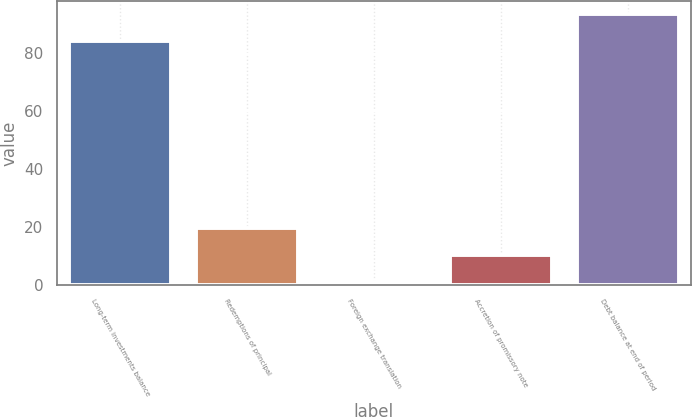<chart> <loc_0><loc_0><loc_500><loc_500><bar_chart><fcel>Long-term investments balance<fcel>Redemptions of principal<fcel>Foreign exchange translation<fcel>Accretion of promissory note<fcel>Debt balance at end of period<nl><fcel>84<fcel>19.6<fcel>1<fcel>10.3<fcel>93.3<nl></chart> 